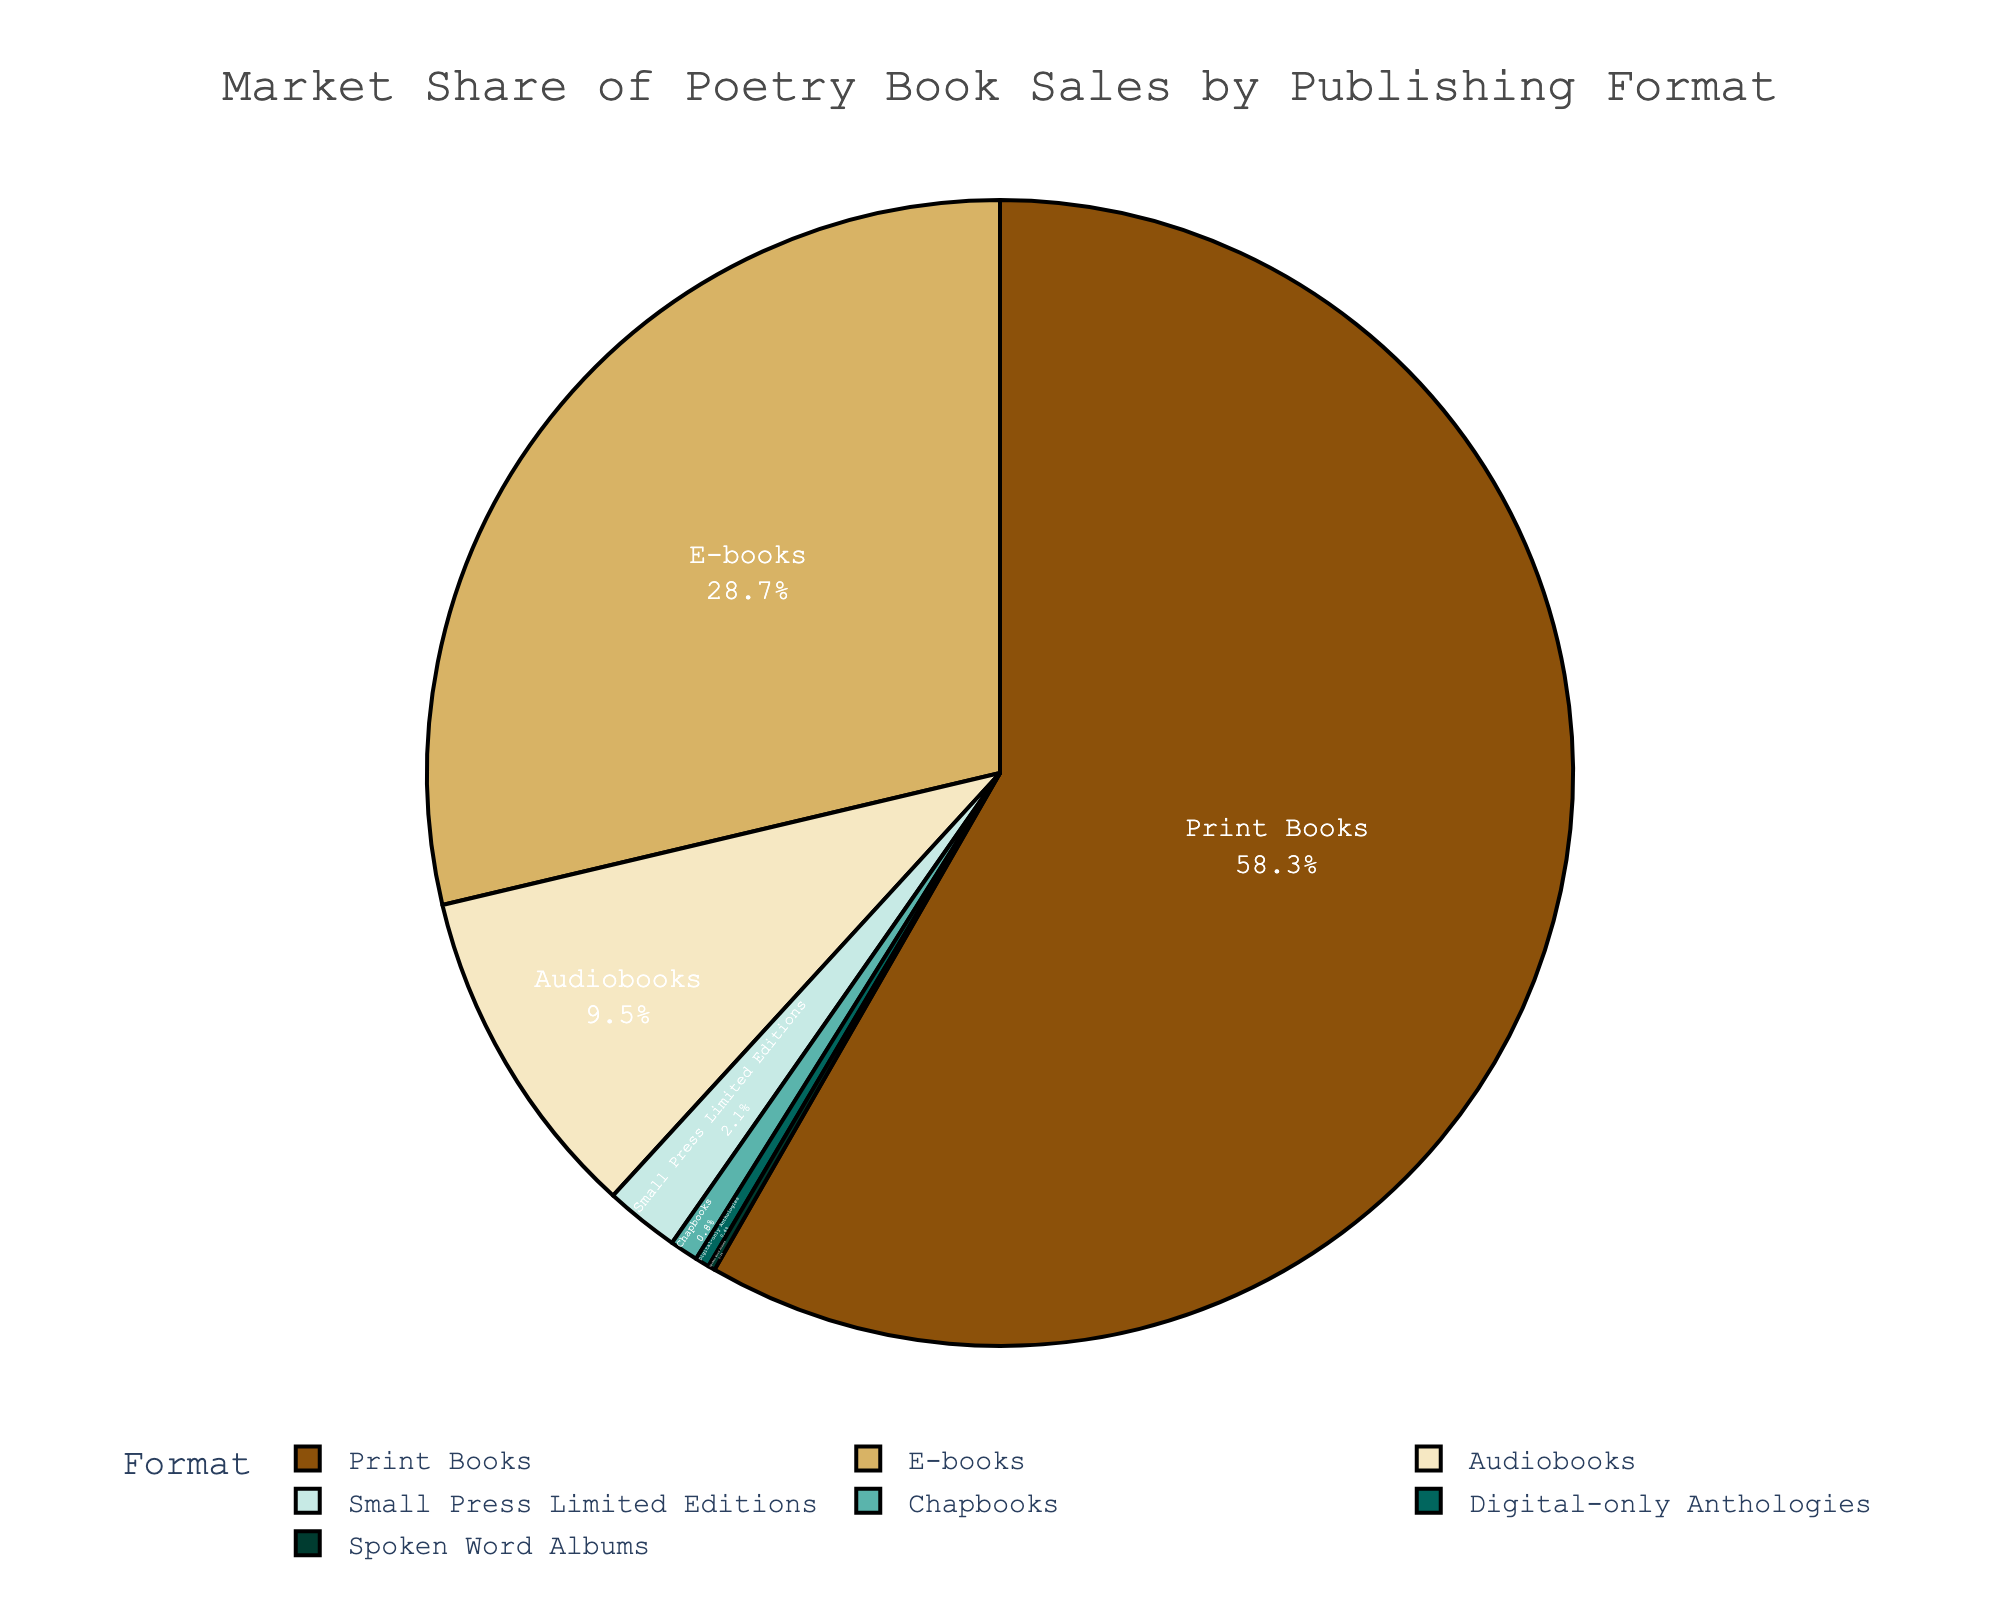What is the market share of print books? The market share of print books is labeled directly on the pie chart segment.
Answer: 58.3% Which format has the largest market share? By examining the size of the pie chart segments, the largest segment corresponds to print books, which have the highest market share.
Answer: Print Books What is the combined market share of audiobooks and e-books? The market shares of audiobooks and e-books are 9.5% and 28.7% respectively. Adding these together: 9.5% + 28.7% = 38.2%.
Answer: 38.2% What percentage of the market is comprised of formats other than print books? The market share for print books is 58.3%. The total market share is 100%. Thus, the market share for all other formats is 100% - 58.3% = 41.7%.
Answer: 41.7% Which format has the smallest market share? The smallest pie chart segment corresponds to Spoken Word Albums, which have the least market share.
Answer: Spoken Word Albums By how much does the market share of e-books exceed the market share of print books? The market share of print books is 58.3% and the market share of e-books is 28.7%. The difference is 58.3% - 28.7% = 29.6%.
Answer: 29.6% Is the combined market share of Chapbooks and Digital-only Anthologies more than 1%? The market share of Chapbooks is 0.8% and the market share of Digital-only Anthologies is 0.4%. Adding these together: 0.8% + 0.4% = 1.2%, which is more than 1%.
Answer: Yes How many formats have a market share greater than 10%? Identifying the segments with more than 10% yields: Print Books (58.3%) and E-books (28.7%). Two formats have a market share greater than 10%.
Answer: 2 